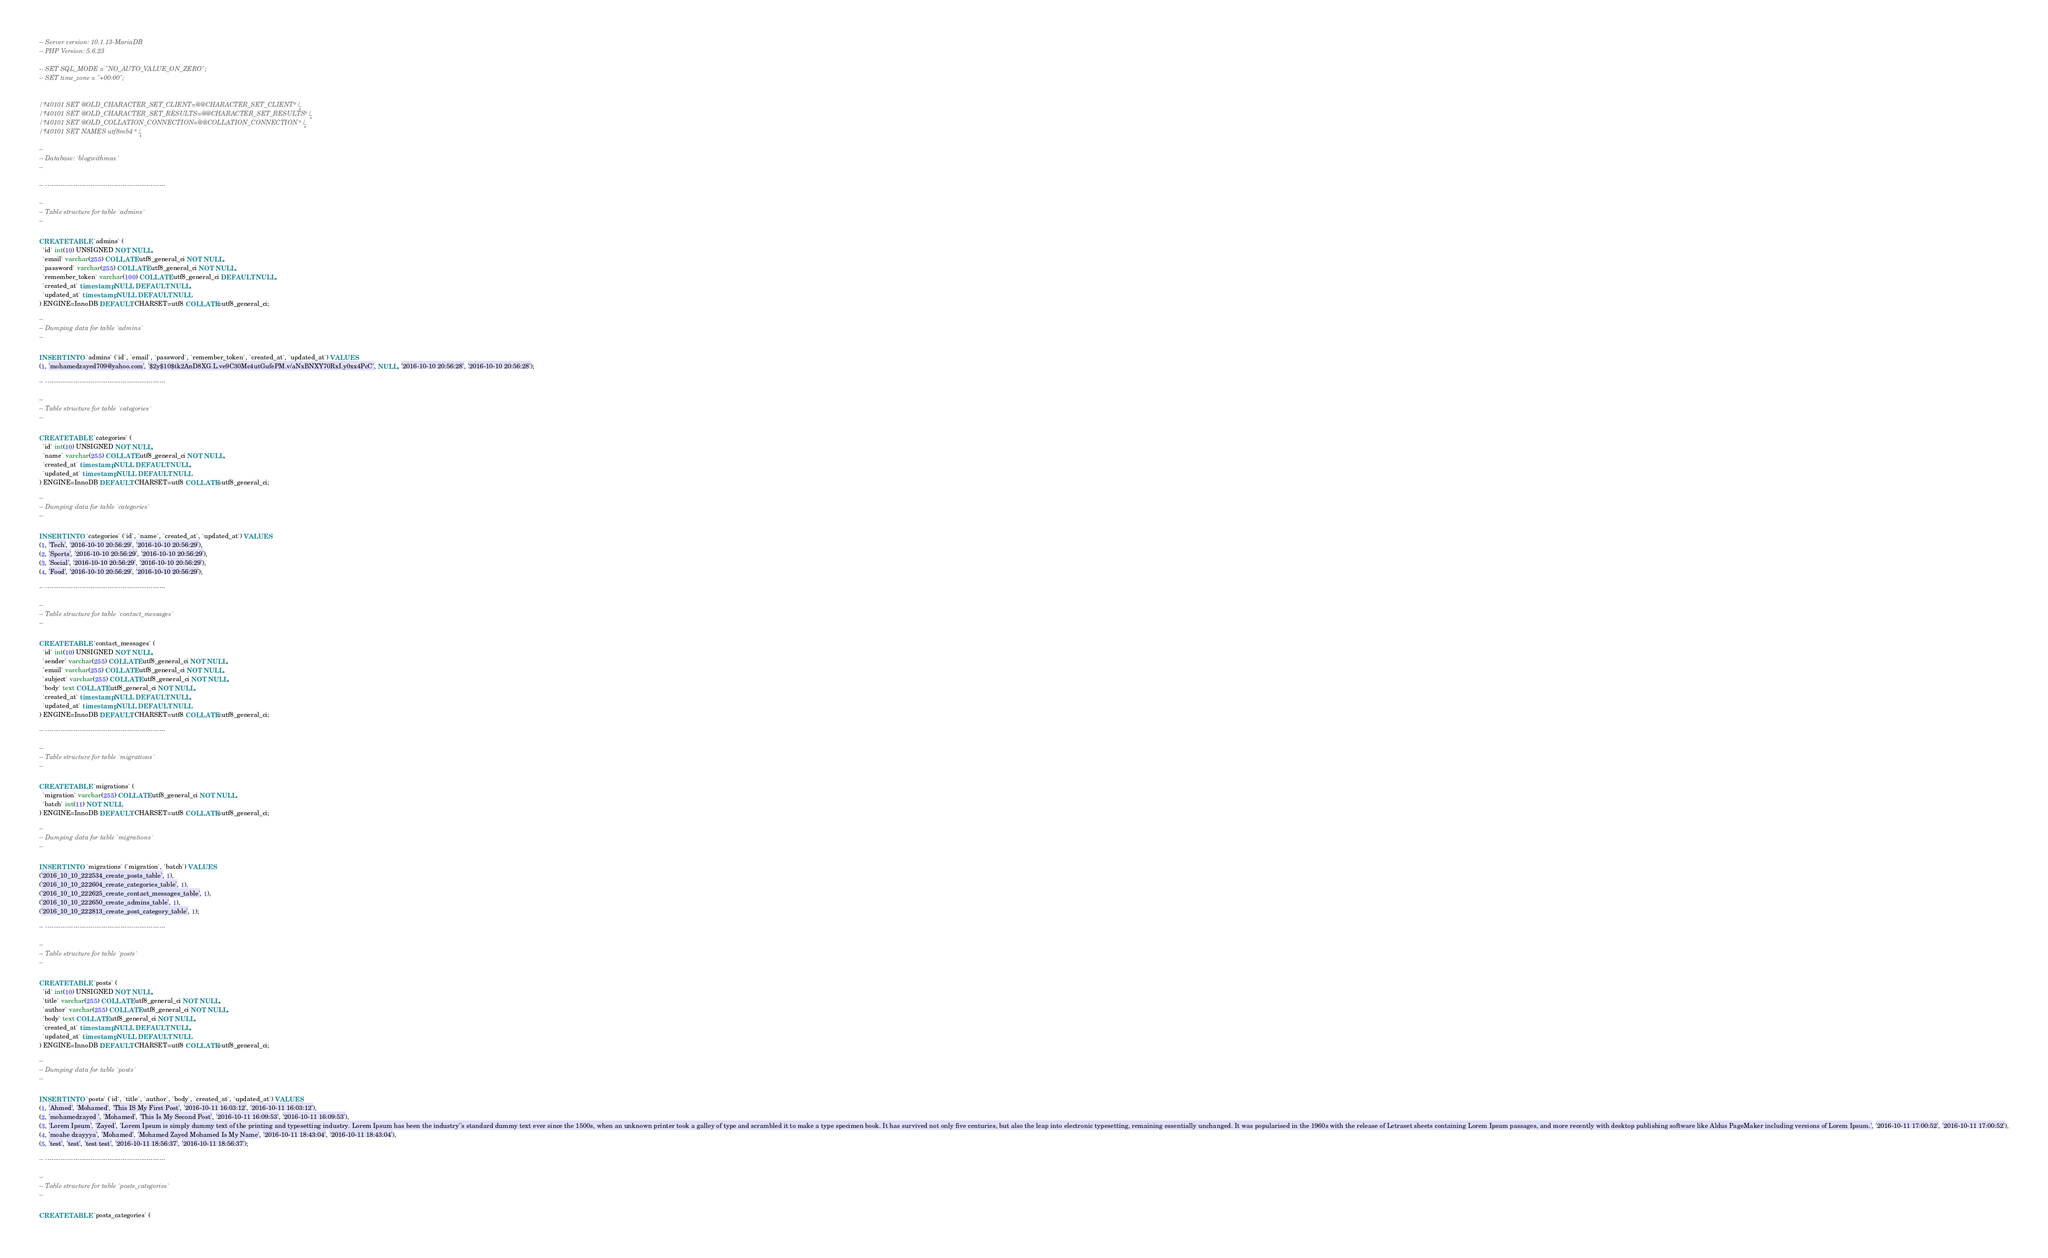Convert code to text. <code><loc_0><loc_0><loc_500><loc_500><_SQL_>-- Server version: 10.1.13-MariaDB
-- PHP Version: 5.6.23

-- SET SQL_MODE = "NO_AUTO_VALUE_ON_ZERO";
-- SET time_zone = "+00:00";


/*!40101 SET @OLD_CHARACTER_SET_CLIENT=@@CHARACTER_SET_CLIENT */;
/*!40101 SET @OLD_CHARACTER_SET_RESULTS=@@CHARACTER_SET_RESULTS */;
/*!40101 SET @OLD_COLLATION_CONNECTION=@@COLLATION_CONNECTION */;
/*!40101 SET NAMES utf8mb4 */;

--
-- Database: `blogwithmax`
--

-- --------------------------------------------------------

--
-- Table structure for table `admins`
--

CREATE TABLE `admins` (
  `id` int(10) UNSIGNED NOT NULL,
  `email` varchar(255) COLLATE utf8_general_ci NOT NULL,
  `password` varchar(255) COLLATE utf8_general_ci NOT NULL,
  `remember_token` varchar(100) COLLATE utf8_general_ci DEFAULT NULL,
  `created_at` timestamp NULL DEFAULT NULL,
  `updated_at` timestamp NULL DEFAULT NULL
) ENGINE=InnoDB DEFAULT CHARSET=utf8 COLLATE=utf8_general_ci;

--
-- Dumping data for table `admins`
--

INSERT INTO `admins` (`id`, `email`, `password`, `remember_token`, `created_at`, `updated_at`) VALUES
(1, 'mohamedzayed709@yahoo.com', '$2y$10$tk2AnD8XG.L.ve9C30Mc4utGufePM.v/aNxBNXY70RxI.y0xx4PcC', NULL, '2016-10-10 20:56:28', '2016-10-10 20:56:28');

-- --------------------------------------------------------

--
-- Table structure for table `categories`
--

CREATE TABLE `categories` (
  `id` int(10) UNSIGNED NOT NULL,
  `name` varchar(255) COLLATE utf8_general_ci NOT NULL,
  `created_at` timestamp NULL DEFAULT NULL,
  `updated_at` timestamp NULL DEFAULT NULL
) ENGINE=InnoDB DEFAULT CHARSET=utf8 COLLATE=utf8_general_ci;

--
-- Dumping data for table `categories`
--

INSERT INTO `categories` (`id`, `name`, `created_at`, `updated_at`) VALUES
(1, 'Tech', '2016-10-10 20:56:29', '2016-10-10 20:56:29'),
(2, 'Sports', '2016-10-10 20:56:29', '2016-10-10 20:56:29'),
(3, 'Social', '2016-10-10 20:56:29', '2016-10-10 20:56:29'),
(4, 'Food', '2016-10-10 20:56:29', '2016-10-10 20:56:29');

-- --------------------------------------------------------

--
-- Table structure for table `contact_messages`
--

CREATE TABLE `contact_messages` (
  `id` int(10) UNSIGNED NOT NULL,
  `sender` varchar(255) COLLATE utf8_general_ci NOT NULL,
  `email` varchar(255) COLLATE utf8_general_ci NOT NULL,
  `subject` varchar(255) COLLATE utf8_general_ci NOT NULL,
  `body` text COLLATE utf8_general_ci NOT NULL,
  `created_at` timestamp NULL DEFAULT NULL,
  `updated_at` timestamp NULL DEFAULT NULL
) ENGINE=InnoDB DEFAULT CHARSET=utf8 COLLATE=utf8_general_ci;

-- --------------------------------------------------------

--
-- Table structure for table `migrations`
--

CREATE TABLE `migrations` (
  `migration` varchar(255) COLLATE utf8_general_ci NOT NULL,
  `batch` int(11) NOT NULL
) ENGINE=InnoDB DEFAULT CHARSET=utf8 COLLATE=utf8_general_ci;

--
-- Dumping data for table `migrations`
--

INSERT INTO `migrations` (`migration`, `batch`) VALUES
('2016_10_10_222534_create_posts_table', 1),
('2016_10_10_222604_create_categories_table', 1),
('2016_10_10_222625_create_contact_messages_table', 1),
('2016_10_10_222650_create_admins_table', 1),
('2016_10_10_222813_create_post_category_table', 1);

-- --------------------------------------------------------

--
-- Table structure for table `posts`
--

CREATE TABLE `posts` (
  `id` int(10) UNSIGNED NOT NULL,
  `title` varchar(255) COLLATE utf8_general_ci NOT NULL,
  `author` varchar(255) COLLATE utf8_general_ci NOT NULL,
  `body` text COLLATE utf8_general_ci NOT NULL,
  `created_at` timestamp NULL DEFAULT NULL,
  `updated_at` timestamp NULL DEFAULT NULL
) ENGINE=InnoDB DEFAULT CHARSET=utf8 COLLATE=utf8_general_ci;

--
-- Dumping data for table `posts`
--

INSERT INTO `posts` (`id`, `title`, `author`, `body`, `created_at`, `updated_at`) VALUES
(1, 'Ahmed', 'Mohamed', 'This IS My First Post', '2016-10-11 16:03:12', '2016-10-11 16:03:12'),
(2, 'mohamedzayed ', 'Mohamed', 'This Is My Second Post', '2016-10-11 16:09:53', '2016-10-11 16:09:53'),
(3, 'Lorem Ipsum', 'Zayed', 'Lorem Ipsum is simply dummy text of the printing and typesetting industry. Lorem Ipsum has been the industry''s standard dummy text ever since the 1500s, when an unknown printer took a galley of type and scrambled it to make a type specimen book. It has survived not only five centuries, but also the leap into electronic typesetting, remaining essentially unchanged. It was popularised in the 1960s with the release of Letraset sheets containing Lorem Ipsum passages, and more recently with desktop publishing software like Aldus PageMaker including versions of Lorem Ipsum.', '2016-10-11 17:00:52', '2016-10-11 17:00:52'),
(4, 'moahe dzayyya', 'Mohamed', 'Mohamed Zayed Mohamed Is My Name', '2016-10-11 18:43:04', '2016-10-11 18:43:04'),
(5, 'test', 'test', 'test test', '2016-10-11 18:56:37', '2016-10-11 18:56:37');

-- --------------------------------------------------------

--
-- Table structure for table `posts_categories`
--

CREATE TABLE `posts_categories` (</code> 